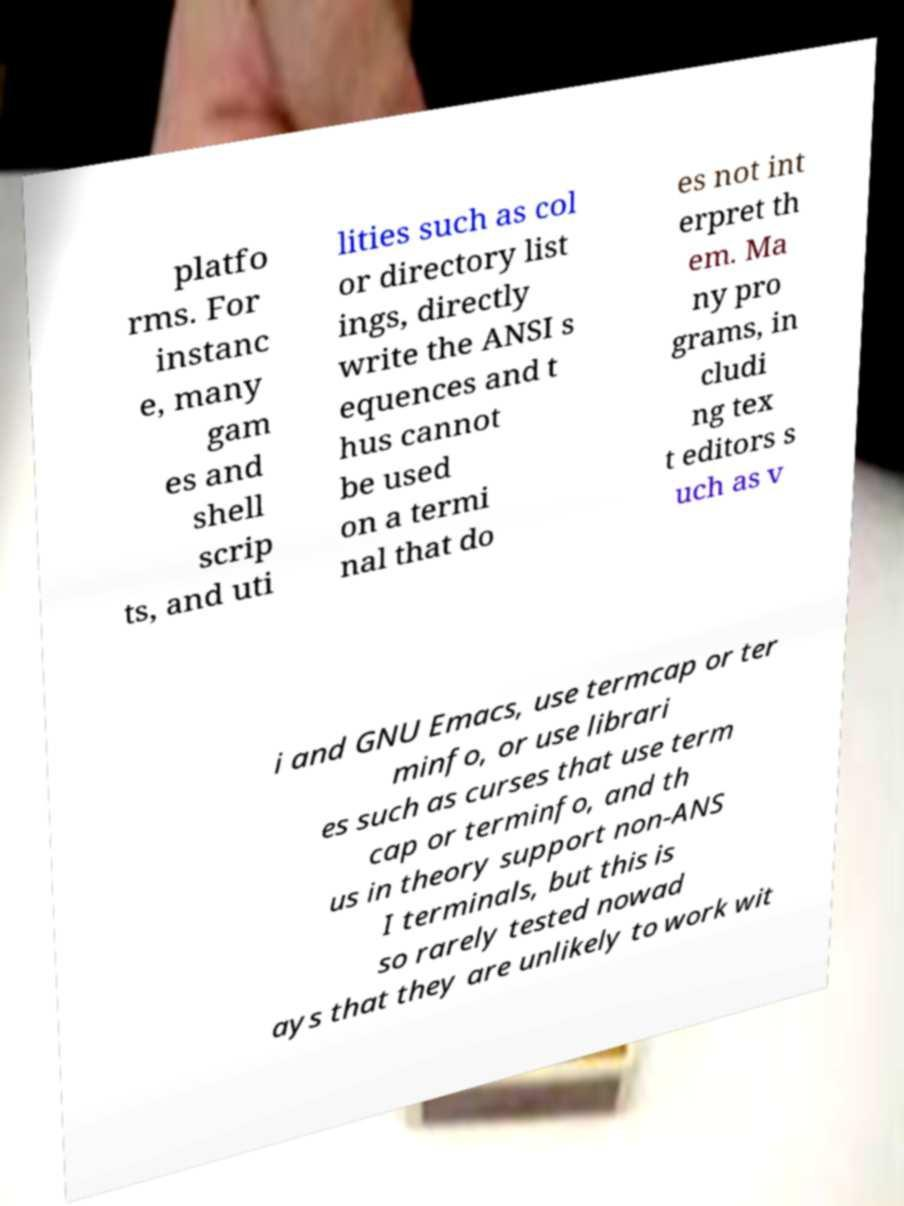What messages or text are displayed in this image? I need them in a readable, typed format. platfo rms. For instanc e, many gam es and shell scrip ts, and uti lities such as col or directory list ings, directly write the ANSI s equences and t hus cannot be used on a termi nal that do es not int erpret th em. Ma ny pro grams, in cludi ng tex t editors s uch as v i and GNU Emacs, use termcap or ter minfo, or use librari es such as curses that use term cap or terminfo, and th us in theory support non-ANS I terminals, but this is so rarely tested nowad ays that they are unlikely to work wit 